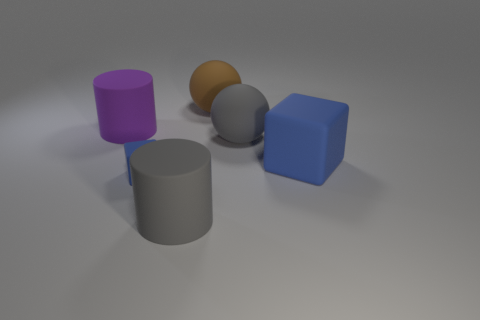What number of other things are there of the same color as the big matte cube?
Your response must be concise. 1. Is the big block the same color as the small matte object?
Offer a terse response. Yes. How many large gray spheres are there?
Give a very brief answer. 1. There is a cylinder that is to the left of the rubber cube that is in front of the big matte cube; what is it made of?
Give a very brief answer. Rubber. There is a blue object that is the same size as the gray rubber ball; what material is it?
Give a very brief answer. Rubber. There is a blue matte object to the right of the gray cylinder; does it have the same size as the big gray matte sphere?
Provide a succinct answer. Yes. Does the matte thing behind the large purple cylinder have the same shape as the purple thing?
Provide a succinct answer. No. How many objects are either small blue matte objects or blue cubes behind the tiny object?
Provide a short and direct response. 2. Is the number of large purple cylinders less than the number of rubber spheres?
Make the answer very short. Yes. Are there more big green matte balls than rubber objects?
Offer a very short reply. No. 